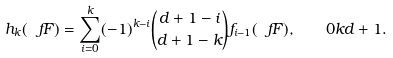Convert formula to latex. <formula><loc_0><loc_0><loc_500><loc_500>h _ { k } ( \ f F ) = \sum _ { i = 0 } ^ { k } ( - 1 ) ^ { k - i } \binom { d + 1 - i } { d + 1 - k } f _ { i - 1 } ( \ f F ) , \quad 0 k d + 1 .</formula> 